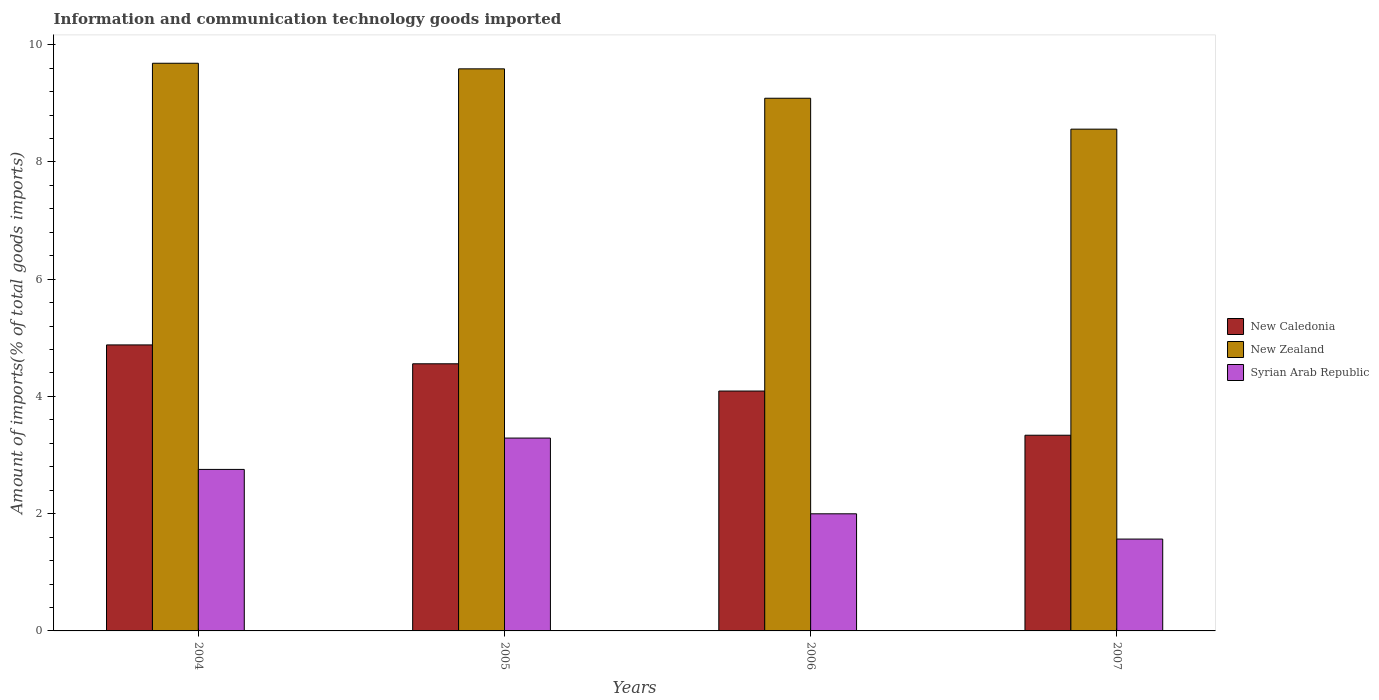How many different coloured bars are there?
Your answer should be very brief. 3. How many groups of bars are there?
Your answer should be very brief. 4. Are the number of bars per tick equal to the number of legend labels?
Give a very brief answer. Yes. How many bars are there on the 3rd tick from the left?
Provide a short and direct response. 3. How many bars are there on the 2nd tick from the right?
Your answer should be very brief. 3. What is the label of the 3rd group of bars from the left?
Provide a short and direct response. 2006. What is the amount of goods imported in Syrian Arab Republic in 2006?
Make the answer very short. 2. Across all years, what is the maximum amount of goods imported in New Zealand?
Make the answer very short. 9.68. Across all years, what is the minimum amount of goods imported in New Zealand?
Give a very brief answer. 8.56. In which year was the amount of goods imported in New Caledonia maximum?
Your response must be concise. 2004. What is the total amount of goods imported in New Caledonia in the graph?
Offer a terse response. 16.86. What is the difference between the amount of goods imported in New Zealand in 2004 and that in 2006?
Keep it short and to the point. 0.6. What is the difference between the amount of goods imported in New Zealand in 2005 and the amount of goods imported in Syrian Arab Republic in 2006?
Your response must be concise. 7.59. What is the average amount of goods imported in Syrian Arab Republic per year?
Your answer should be very brief. 2.4. In the year 2005, what is the difference between the amount of goods imported in New Caledonia and amount of goods imported in Syrian Arab Republic?
Ensure brevity in your answer.  1.27. What is the ratio of the amount of goods imported in New Zealand in 2004 to that in 2005?
Offer a very short reply. 1.01. Is the difference between the amount of goods imported in New Caledonia in 2004 and 2006 greater than the difference between the amount of goods imported in Syrian Arab Republic in 2004 and 2006?
Offer a very short reply. Yes. What is the difference between the highest and the second highest amount of goods imported in New Caledonia?
Provide a short and direct response. 0.32. What is the difference between the highest and the lowest amount of goods imported in New Caledonia?
Your response must be concise. 1.54. What does the 2nd bar from the left in 2007 represents?
Your response must be concise. New Zealand. What does the 2nd bar from the right in 2004 represents?
Your answer should be compact. New Zealand. Is it the case that in every year, the sum of the amount of goods imported in Syrian Arab Republic and amount of goods imported in New Caledonia is greater than the amount of goods imported in New Zealand?
Make the answer very short. No. How many bars are there?
Provide a succinct answer. 12. Are all the bars in the graph horizontal?
Make the answer very short. No. How many years are there in the graph?
Give a very brief answer. 4. What is the difference between two consecutive major ticks on the Y-axis?
Provide a short and direct response. 2. Does the graph contain any zero values?
Your response must be concise. No. Does the graph contain grids?
Provide a succinct answer. No. Where does the legend appear in the graph?
Your answer should be very brief. Center right. What is the title of the graph?
Provide a short and direct response. Information and communication technology goods imported. Does "Upper middle income" appear as one of the legend labels in the graph?
Give a very brief answer. No. What is the label or title of the Y-axis?
Keep it short and to the point. Amount of imports(% of total goods imports). What is the Amount of imports(% of total goods imports) of New Caledonia in 2004?
Offer a very short reply. 4.88. What is the Amount of imports(% of total goods imports) in New Zealand in 2004?
Offer a terse response. 9.68. What is the Amount of imports(% of total goods imports) of Syrian Arab Republic in 2004?
Your answer should be very brief. 2.75. What is the Amount of imports(% of total goods imports) of New Caledonia in 2005?
Your answer should be compact. 4.56. What is the Amount of imports(% of total goods imports) in New Zealand in 2005?
Provide a short and direct response. 9.59. What is the Amount of imports(% of total goods imports) in Syrian Arab Republic in 2005?
Keep it short and to the point. 3.29. What is the Amount of imports(% of total goods imports) in New Caledonia in 2006?
Provide a succinct answer. 4.09. What is the Amount of imports(% of total goods imports) of New Zealand in 2006?
Give a very brief answer. 9.09. What is the Amount of imports(% of total goods imports) of Syrian Arab Republic in 2006?
Keep it short and to the point. 2. What is the Amount of imports(% of total goods imports) in New Caledonia in 2007?
Ensure brevity in your answer.  3.34. What is the Amount of imports(% of total goods imports) in New Zealand in 2007?
Provide a short and direct response. 8.56. What is the Amount of imports(% of total goods imports) in Syrian Arab Republic in 2007?
Keep it short and to the point. 1.57. Across all years, what is the maximum Amount of imports(% of total goods imports) of New Caledonia?
Your response must be concise. 4.88. Across all years, what is the maximum Amount of imports(% of total goods imports) in New Zealand?
Offer a very short reply. 9.68. Across all years, what is the maximum Amount of imports(% of total goods imports) in Syrian Arab Republic?
Your response must be concise. 3.29. Across all years, what is the minimum Amount of imports(% of total goods imports) in New Caledonia?
Your answer should be very brief. 3.34. Across all years, what is the minimum Amount of imports(% of total goods imports) of New Zealand?
Your response must be concise. 8.56. Across all years, what is the minimum Amount of imports(% of total goods imports) in Syrian Arab Republic?
Your answer should be compact. 1.57. What is the total Amount of imports(% of total goods imports) in New Caledonia in the graph?
Offer a terse response. 16.86. What is the total Amount of imports(% of total goods imports) in New Zealand in the graph?
Your answer should be very brief. 36.92. What is the total Amount of imports(% of total goods imports) of Syrian Arab Republic in the graph?
Provide a succinct answer. 9.61. What is the difference between the Amount of imports(% of total goods imports) in New Caledonia in 2004 and that in 2005?
Give a very brief answer. 0.32. What is the difference between the Amount of imports(% of total goods imports) of New Zealand in 2004 and that in 2005?
Provide a succinct answer. 0.1. What is the difference between the Amount of imports(% of total goods imports) in Syrian Arab Republic in 2004 and that in 2005?
Make the answer very short. -0.53. What is the difference between the Amount of imports(% of total goods imports) of New Caledonia in 2004 and that in 2006?
Provide a succinct answer. 0.79. What is the difference between the Amount of imports(% of total goods imports) in New Zealand in 2004 and that in 2006?
Provide a succinct answer. 0.6. What is the difference between the Amount of imports(% of total goods imports) in Syrian Arab Republic in 2004 and that in 2006?
Offer a terse response. 0.76. What is the difference between the Amount of imports(% of total goods imports) in New Caledonia in 2004 and that in 2007?
Offer a very short reply. 1.54. What is the difference between the Amount of imports(% of total goods imports) of New Zealand in 2004 and that in 2007?
Provide a short and direct response. 1.12. What is the difference between the Amount of imports(% of total goods imports) in Syrian Arab Republic in 2004 and that in 2007?
Your answer should be very brief. 1.19. What is the difference between the Amount of imports(% of total goods imports) in New Caledonia in 2005 and that in 2006?
Ensure brevity in your answer.  0.47. What is the difference between the Amount of imports(% of total goods imports) in New Zealand in 2005 and that in 2006?
Keep it short and to the point. 0.5. What is the difference between the Amount of imports(% of total goods imports) of Syrian Arab Republic in 2005 and that in 2006?
Your response must be concise. 1.29. What is the difference between the Amount of imports(% of total goods imports) in New Caledonia in 2005 and that in 2007?
Your answer should be compact. 1.22. What is the difference between the Amount of imports(% of total goods imports) of New Zealand in 2005 and that in 2007?
Provide a short and direct response. 1.03. What is the difference between the Amount of imports(% of total goods imports) in Syrian Arab Republic in 2005 and that in 2007?
Provide a short and direct response. 1.72. What is the difference between the Amount of imports(% of total goods imports) of New Caledonia in 2006 and that in 2007?
Your answer should be very brief. 0.75. What is the difference between the Amount of imports(% of total goods imports) in New Zealand in 2006 and that in 2007?
Your response must be concise. 0.53. What is the difference between the Amount of imports(% of total goods imports) in Syrian Arab Republic in 2006 and that in 2007?
Offer a terse response. 0.43. What is the difference between the Amount of imports(% of total goods imports) of New Caledonia in 2004 and the Amount of imports(% of total goods imports) of New Zealand in 2005?
Your answer should be very brief. -4.71. What is the difference between the Amount of imports(% of total goods imports) in New Caledonia in 2004 and the Amount of imports(% of total goods imports) in Syrian Arab Republic in 2005?
Make the answer very short. 1.59. What is the difference between the Amount of imports(% of total goods imports) in New Zealand in 2004 and the Amount of imports(% of total goods imports) in Syrian Arab Republic in 2005?
Provide a short and direct response. 6.39. What is the difference between the Amount of imports(% of total goods imports) of New Caledonia in 2004 and the Amount of imports(% of total goods imports) of New Zealand in 2006?
Provide a succinct answer. -4.21. What is the difference between the Amount of imports(% of total goods imports) in New Caledonia in 2004 and the Amount of imports(% of total goods imports) in Syrian Arab Republic in 2006?
Your response must be concise. 2.88. What is the difference between the Amount of imports(% of total goods imports) of New Zealand in 2004 and the Amount of imports(% of total goods imports) of Syrian Arab Republic in 2006?
Keep it short and to the point. 7.68. What is the difference between the Amount of imports(% of total goods imports) of New Caledonia in 2004 and the Amount of imports(% of total goods imports) of New Zealand in 2007?
Offer a very short reply. -3.68. What is the difference between the Amount of imports(% of total goods imports) in New Caledonia in 2004 and the Amount of imports(% of total goods imports) in Syrian Arab Republic in 2007?
Ensure brevity in your answer.  3.31. What is the difference between the Amount of imports(% of total goods imports) of New Zealand in 2004 and the Amount of imports(% of total goods imports) of Syrian Arab Republic in 2007?
Ensure brevity in your answer.  8.12. What is the difference between the Amount of imports(% of total goods imports) of New Caledonia in 2005 and the Amount of imports(% of total goods imports) of New Zealand in 2006?
Make the answer very short. -4.53. What is the difference between the Amount of imports(% of total goods imports) of New Caledonia in 2005 and the Amount of imports(% of total goods imports) of Syrian Arab Republic in 2006?
Your answer should be compact. 2.56. What is the difference between the Amount of imports(% of total goods imports) in New Zealand in 2005 and the Amount of imports(% of total goods imports) in Syrian Arab Republic in 2006?
Provide a succinct answer. 7.59. What is the difference between the Amount of imports(% of total goods imports) of New Caledonia in 2005 and the Amount of imports(% of total goods imports) of New Zealand in 2007?
Your response must be concise. -4. What is the difference between the Amount of imports(% of total goods imports) of New Caledonia in 2005 and the Amount of imports(% of total goods imports) of Syrian Arab Republic in 2007?
Your answer should be very brief. 2.99. What is the difference between the Amount of imports(% of total goods imports) in New Zealand in 2005 and the Amount of imports(% of total goods imports) in Syrian Arab Republic in 2007?
Your answer should be very brief. 8.02. What is the difference between the Amount of imports(% of total goods imports) in New Caledonia in 2006 and the Amount of imports(% of total goods imports) in New Zealand in 2007?
Ensure brevity in your answer.  -4.47. What is the difference between the Amount of imports(% of total goods imports) of New Caledonia in 2006 and the Amount of imports(% of total goods imports) of Syrian Arab Republic in 2007?
Offer a very short reply. 2.52. What is the difference between the Amount of imports(% of total goods imports) of New Zealand in 2006 and the Amount of imports(% of total goods imports) of Syrian Arab Republic in 2007?
Your answer should be compact. 7.52. What is the average Amount of imports(% of total goods imports) of New Caledonia per year?
Offer a terse response. 4.22. What is the average Amount of imports(% of total goods imports) in New Zealand per year?
Provide a short and direct response. 9.23. What is the average Amount of imports(% of total goods imports) of Syrian Arab Republic per year?
Your response must be concise. 2.4. In the year 2004, what is the difference between the Amount of imports(% of total goods imports) of New Caledonia and Amount of imports(% of total goods imports) of New Zealand?
Your answer should be very brief. -4.8. In the year 2004, what is the difference between the Amount of imports(% of total goods imports) in New Caledonia and Amount of imports(% of total goods imports) in Syrian Arab Republic?
Offer a terse response. 2.12. In the year 2004, what is the difference between the Amount of imports(% of total goods imports) in New Zealand and Amount of imports(% of total goods imports) in Syrian Arab Republic?
Offer a very short reply. 6.93. In the year 2005, what is the difference between the Amount of imports(% of total goods imports) in New Caledonia and Amount of imports(% of total goods imports) in New Zealand?
Offer a terse response. -5.03. In the year 2005, what is the difference between the Amount of imports(% of total goods imports) of New Caledonia and Amount of imports(% of total goods imports) of Syrian Arab Republic?
Offer a very short reply. 1.27. In the year 2005, what is the difference between the Amount of imports(% of total goods imports) in New Zealand and Amount of imports(% of total goods imports) in Syrian Arab Republic?
Your answer should be compact. 6.3. In the year 2006, what is the difference between the Amount of imports(% of total goods imports) in New Caledonia and Amount of imports(% of total goods imports) in New Zealand?
Your response must be concise. -4.99. In the year 2006, what is the difference between the Amount of imports(% of total goods imports) of New Caledonia and Amount of imports(% of total goods imports) of Syrian Arab Republic?
Keep it short and to the point. 2.09. In the year 2006, what is the difference between the Amount of imports(% of total goods imports) in New Zealand and Amount of imports(% of total goods imports) in Syrian Arab Republic?
Your answer should be compact. 7.09. In the year 2007, what is the difference between the Amount of imports(% of total goods imports) of New Caledonia and Amount of imports(% of total goods imports) of New Zealand?
Your answer should be compact. -5.22. In the year 2007, what is the difference between the Amount of imports(% of total goods imports) in New Caledonia and Amount of imports(% of total goods imports) in Syrian Arab Republic?
Provide a short and direct response. 1.77. In the year 2007, what is the difference between the Amount of imports(% of total goods imports) of New Zealand and Amount of imports(% of total goods imports) of Syrian Arab Republic?
Ensure brevity in your answer.  6.99. What is the ratio of the Amount of imports(% of total goods imports) of New Caledonia in 2004 to that in 2005?
Provide a succinct answer. 1.07. What is the ratio of the Amount of imports(% of total goods imports) in New Zealand in 2004 to that in 2005?
Your response must be concise. 1.01. What is the ratio of the Amount of imports(% of total goods imports) of Syrian Arab Republic in 2004 to that in 2005?
Your response must be concise. 0.84. What is the ratio of the Amount of imports(% of total goods imports) in New Caledonia in 2004 to that in 2006?
Provide a short and direct response. 1.19. What is the ratio of the Amount of imports(% of total goods imports) of New Zealand in 2004 to that in 2006?
Provide a succinct answer. 1.07. What is the ratio of the Amount of imports(% of total goods imports) of Syrian Arab Republic in 2004 to that in 2006?
Your answer should be compact. 1.38. What is the ratio of the Amount of imports(% of total goods imports) of New Caledonia in 2004 to that in 2007?
Provide a short and direct response. 1.46. What is the ratio of the Amount of imports(% of total goods imports) of New Zealand in 2004 to that in 2007?
Offer a terse response. 1.13. What is the ratio of the Amount of imports(% of total goods imports) in Syrian Arab Republic in 2004 to that in 2007?
Provide a succinct answer. 1.76. What is the ratio of the Amount of imports(% of total goods imports) of New Caledonia in 2005 to that in 2006?
Keep it short and to the point. 1.11. What is the ratio of the Amount of imports(% of total goods imports) in New Zealand in 2005 to that in 2006?
Make the answer very short. 1.06. What is the ratio of the Amount of imports(% of total goods imports) of Syrian Arab Republic in 2005 to that in 2006?
Provide a short and direct response. 1.65. What is the ratio of the Amount of imports(% of total goods imports) of New Caledonia in 2005 to that in 2007?
Provide a succinct answer. 1.37. What is the ratio of the Amount of imports(% of total goods imports) of New Zealand in 2005 to that in 2007?
Your answer should be compact. 1.12. What is the ratio of the Amount of imports(% of total goods imports) of Syrian Arab Republic in 2005 to that in 2007?
Offer a terse response. 2.1. What is the ratio of the Amount of imports(% of total goods imports) in New Caledonia in 2006 to that in 2007?
Provide a short and direct response. 1.23. What is the ratio of the Amount of imports(% of total goods imports) in New Zealand in 2006 to that in 2007?
Provide a short and direct response. 1.06. What is the ratio of the Amount of imports(% of total goods imports) in Syrian Arab Republic in 2006 to that in 2007?
Provide a succinct answer. 1.28. What is the difference between the highest and the second highest Amount of imports(% of total goods imports) of New Caledonia?
Provide a short and direct response. 0.32. What is the difference between the highest and the second highest Amount of imports(% of total goods imports) of New Zealand?
Give a very brief answer. 0.1. What is the difference between the highest and the second highest Amount of imports(% of total goods imports) of Syrian Arab Republic?
Keep it short and to the point. 0.53. What is the difference between the highest and the lowest Amount of imports(% of total goods imports) of New Caledonia?
Ensure brevity in your answer.  1.54. What is the difference between the highest and the lowest Amount of imports(% of total goods imports) in New Zealand?
Ensure brevity in your answer.  1.12. What is the difference between the highest and the lowest Amount of imports(% of total goods imports) in Syrian Arab Republic?
Ensure brevity in your answer.  1.72. 